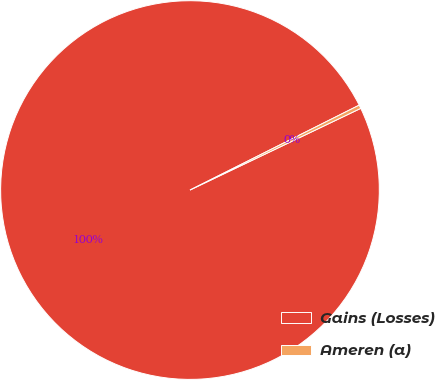Convert chart. <chart><loc_0><loc_0><loc_500><loc_500><pie_chart><fcel>Gains (Losses)<fcel>Ameren (a)<nl><fcel>99.7%<fcel>0.3%<nl></chart> 